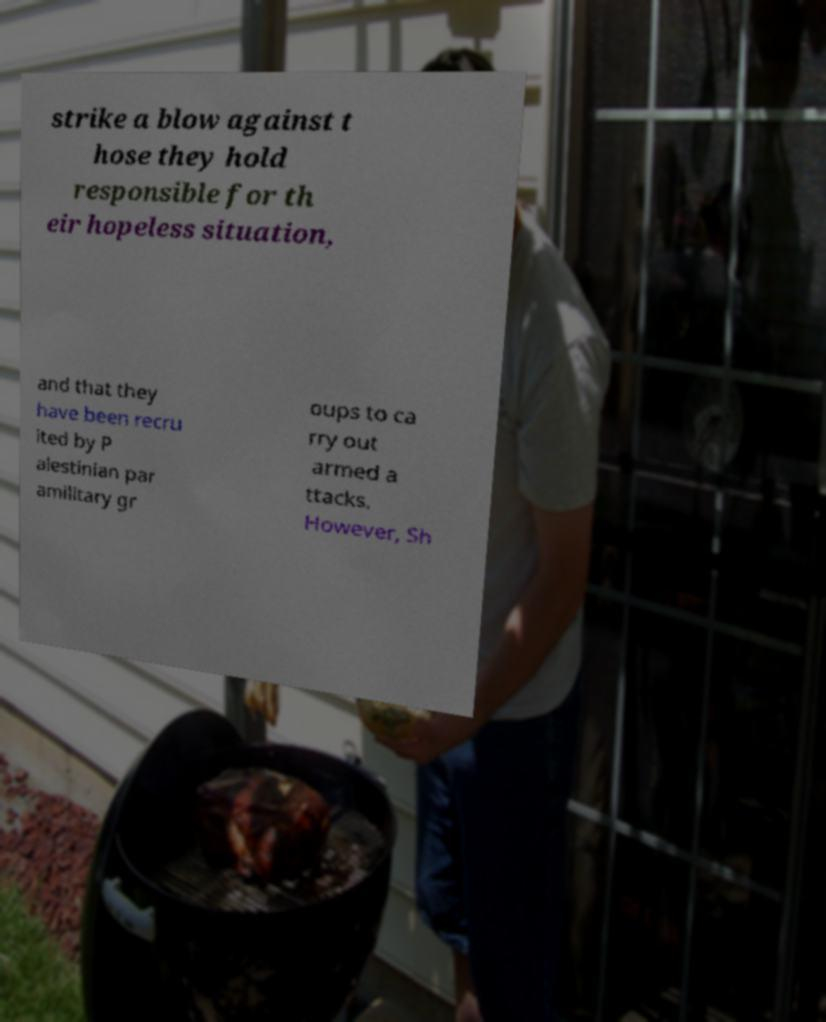Can you accurately transcribe the text from the provided image for me? strike a blow against t hose they hold responsible for th eir hopeless situation, and that they have been recru ited by P alestinian par amilitary gr oups to ca rry out armed a ttacks. However, Sh 